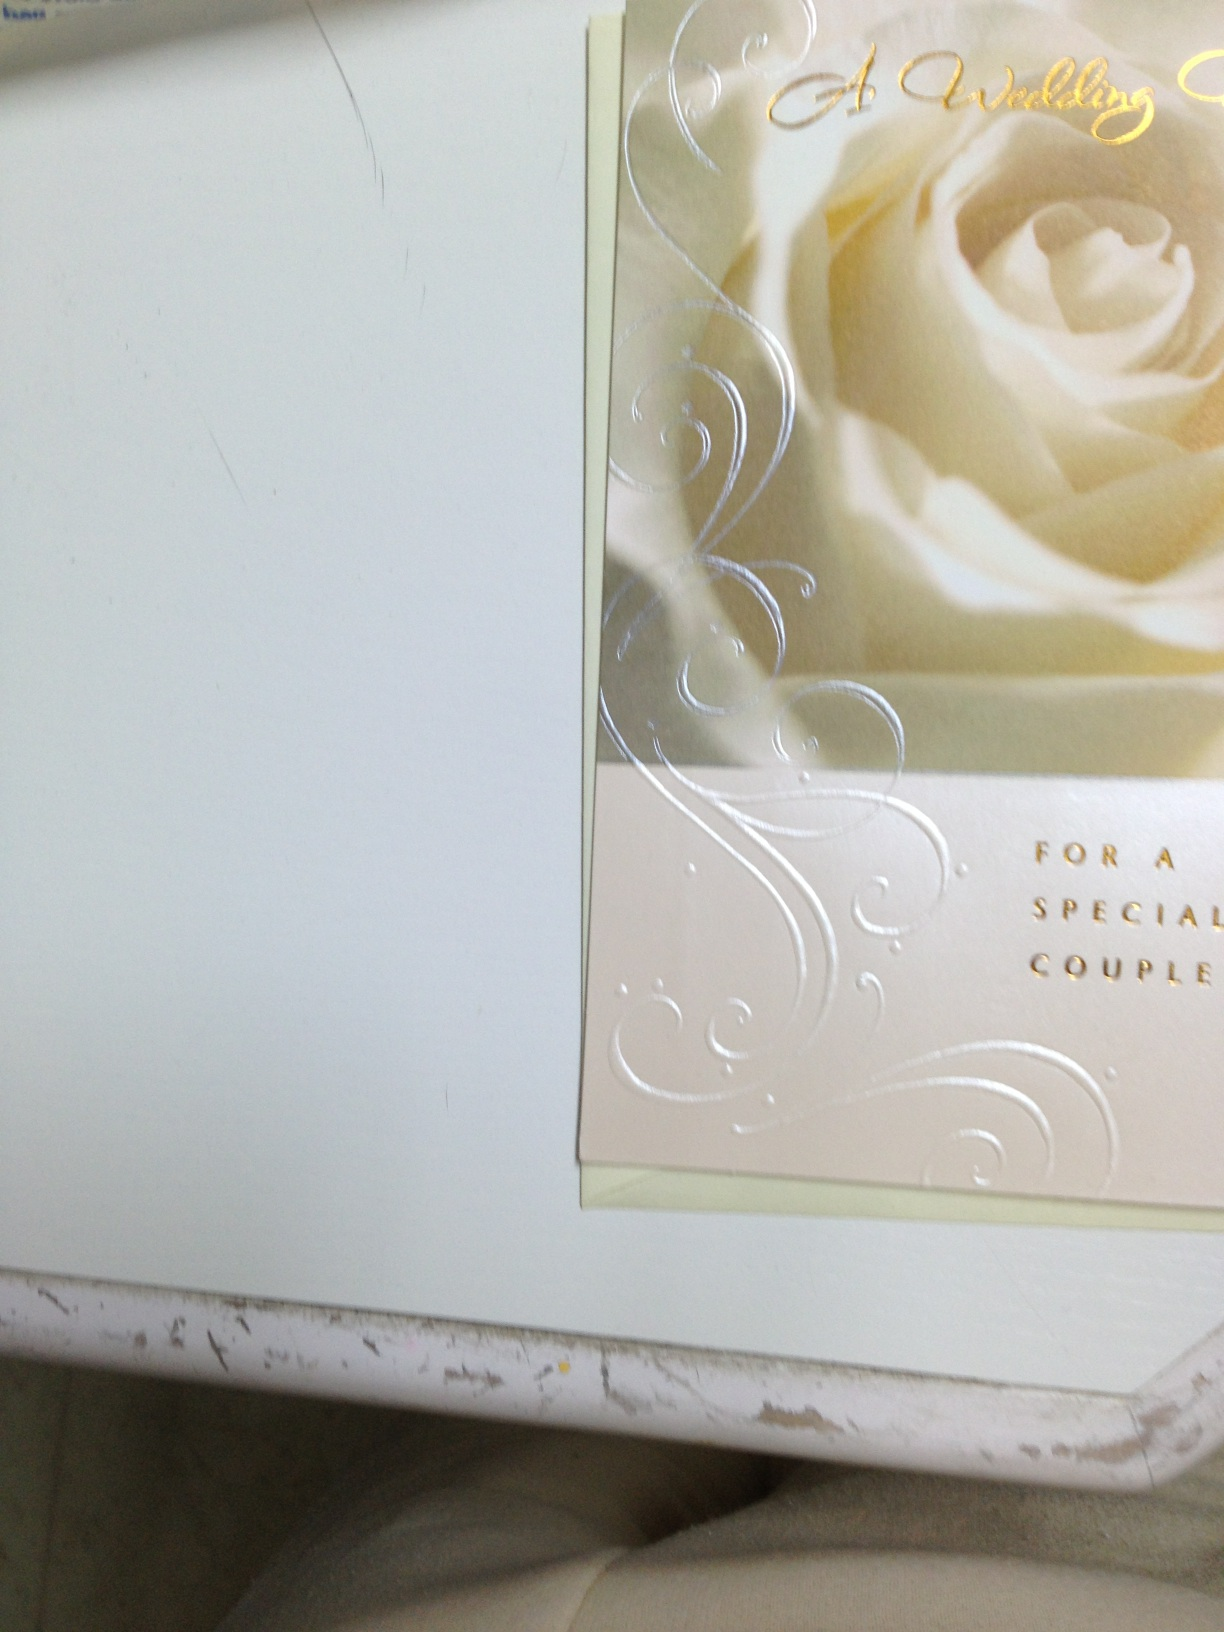What occasions might this card be used for besides weddings? While primarily intended for weddings, this elegant card might also be suitable for anniversaries, particularly major milestones such as a silver or golden anniversary, reflecting love and long-term commitment between a couple. Could this card be customized for personal messages? Yes, there's ample space inside the card for personal handwritten messages, which can be customized to fit the recipients' unique story or extend heartfelt wishes, allowing for a more personal touch. 